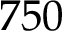Convert formula to latex. <formula><loc_0><loc_0><loc_500><loc_500>7 5 0</formula> 